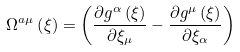Convert formula to latex. <formula><loc_0><loc_0><loc_500><loc_500>\Omega ^ { a \mu } \left ( \xi \right ) = \left ( \frac { \partial g ^ { \alpha } \left ( \xi \right ) } { \partial \xi _ { \mu } } - \frac { \partial g ^ { \mu } \left ( \xi \right ) } { \partial \xi _ { \alpha } } \right )</formula> 